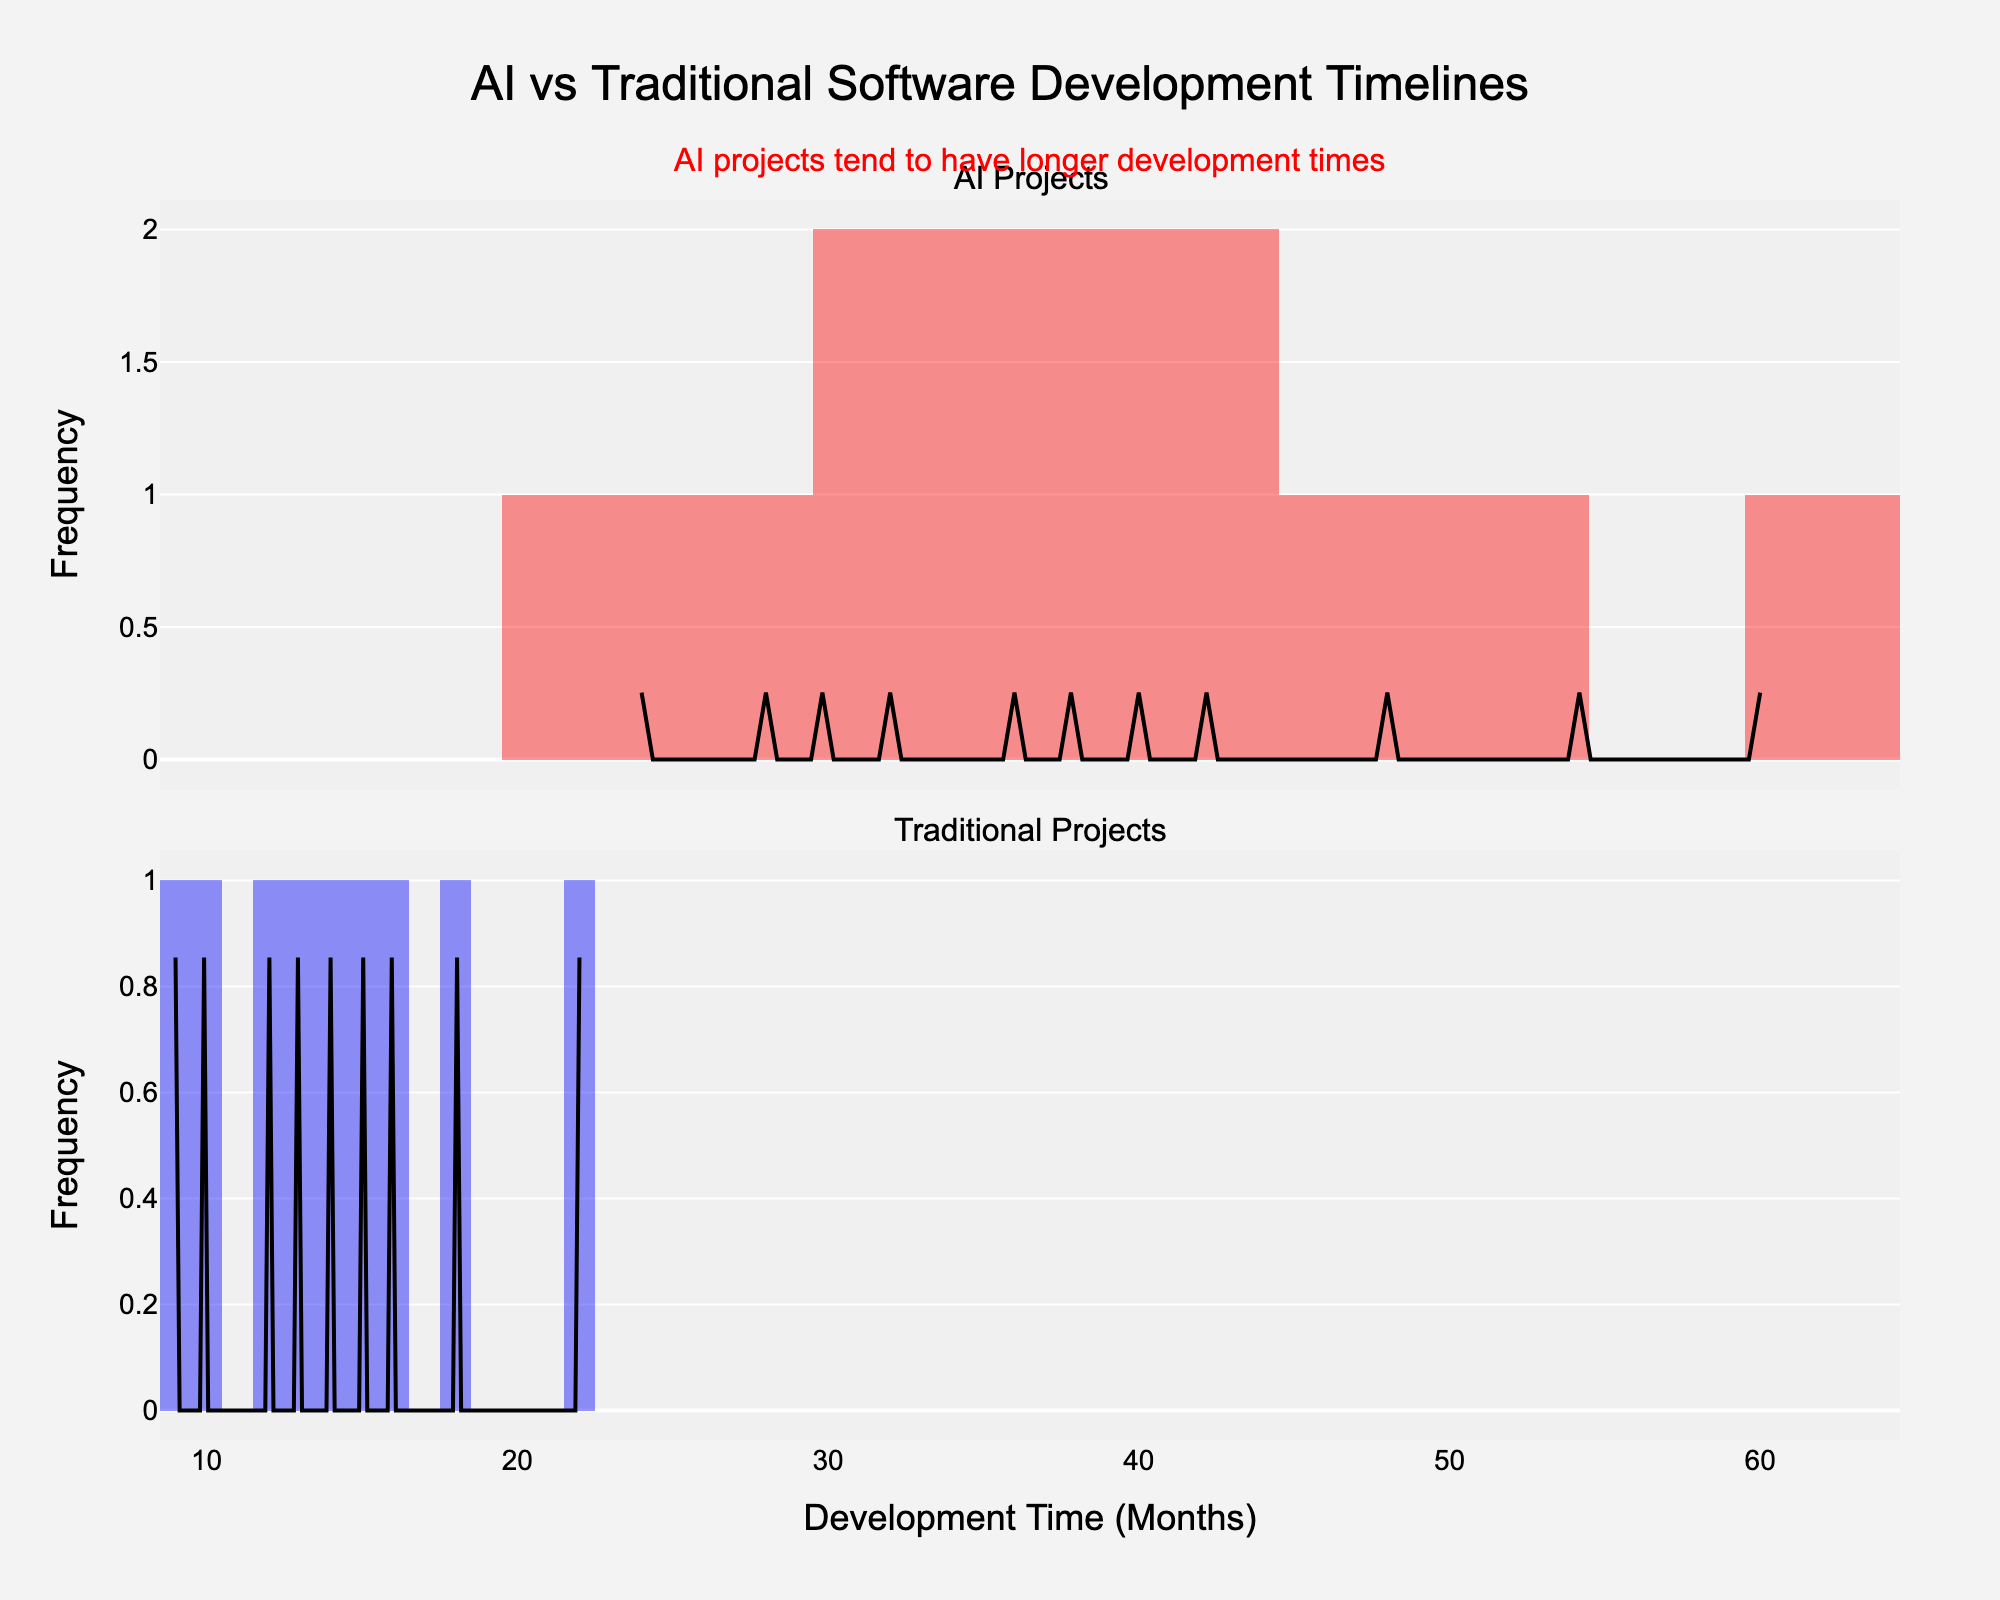What is the title of the figure? The title of the figure is presented at the top center of the plot. It reads "AI vs Traditional Software Development Timelines."
Answer: "AI vs Traditional Software Development Timelines" What does the x-axis represent? The x-axis represents "Development Time (Months)" which indicates the number of months taken to develop the projects.
Answer: Development Time (Months) What is the predominant color used for AI projects in the histogram? The histogram for AI projects uses a reddish color, specifically a shade of red with transparency.
Answer: Red How many AI projects have a development time exceeding 40 months? From the histogram, count the bars corresponding to the development time greater than 40 months. The projects are "IBM Watson", "ChatGPT", "Self-Driving Car AI", "OpenAI GPT-3", and "DeepMind AlphaFold," totaling to 5.
Answer: 5 Which group has the shorter average development time, AI projects or Traditional projects? The traditional projects histogram is generally shifted towards the left compared to AI projects, indicating shorter development times. Therefore, traditional projects have a shorter average development time.
Answer: Traditional projects What is observed about AI projects' development times compared to traditional projects' development times? By looking at the KDE curves and histograms, AI projects are more spread out to the right, indicating they tend to have longer development times.
Answer: AI projects have longer development times How does the peak of the KDE curve for AI projects compare to that of Traditional projects? The KDE curve for traditional projects has its highest peak at a lower development time compared to the peak for AI projects, indicating that traditional projects more frequently have lower development times.
Answer: Traditional projects have a higher peak at lower development times What does the annotation at the top of the figure indicate? The annotation highlights that "AI projects tend to have longer development times" which is an observation derived from the histogram and KDE curves.
Answer: AI projects tend to have longer development times Are there more AI projects or traditional projects in the dataset? By counting the bars in each histogram, we see that traditional projects have more bars, indicating a higher number of projects.
Answer: Traditional projects 